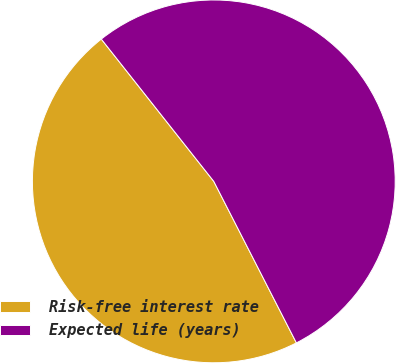Convert chart to OTSL. <chart><loc_0><loc_0><loc_500><loc_500><pie_chart><fcel>Risk-free interest rate<fcel>Expected life (years)<nl><fcel>46.88%<fcel>53.12%<nl></chart> 